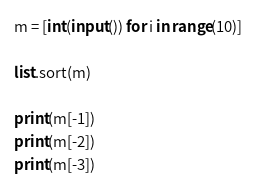<code> <loc_0><loc_0><loc_500><loc_500><_Python_>
m = [int(input()) for i in range(10)]

list.sort(m)

print(m[-1])
print(m[-2])
print(m[-3])
</code> 